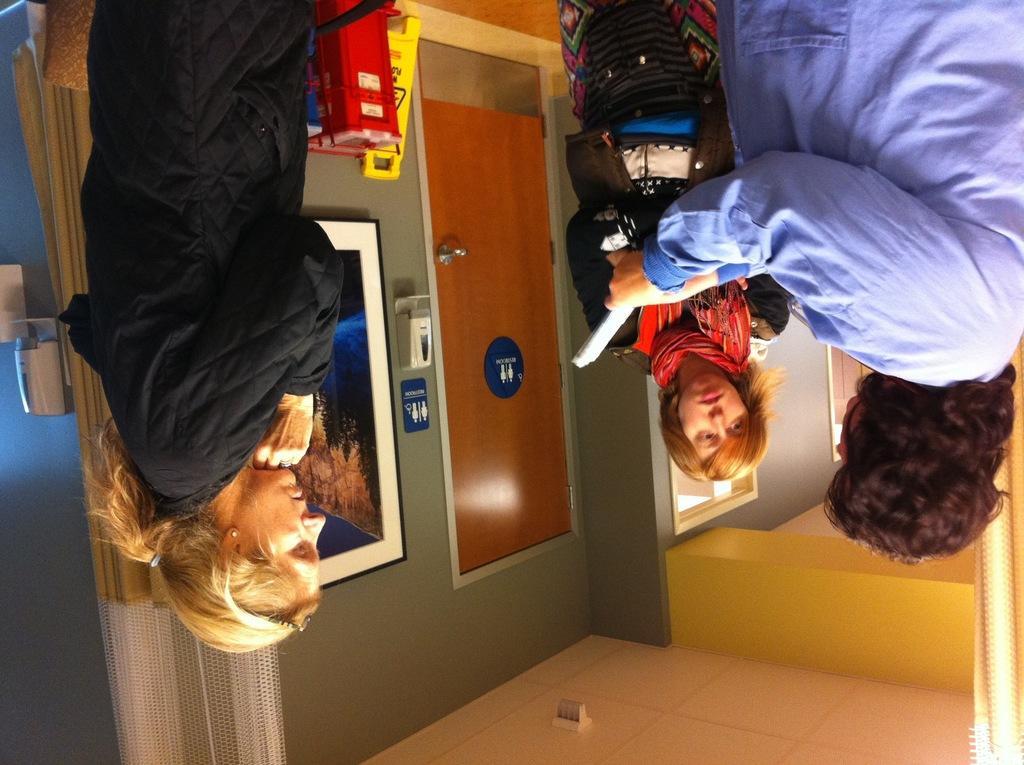In one or two sentences, can you explain what this image depicts? In this image we can see women standing on the floor and one of them is holding papers in her hands. In the background we can see door, sign boards and wall hanging attached to the wall. 